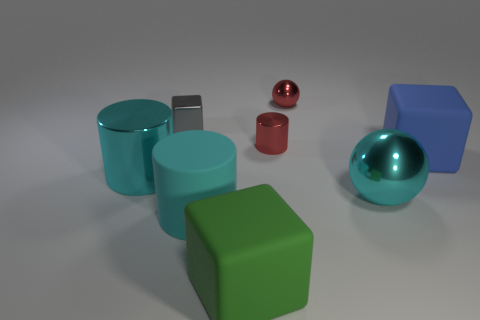How many things are cylinders to the left of the shiny cube or things on the left side of the big sphere?
Keep it short and to the point. 6. There is a big cube on the right side of the big green cube; is its color the same as the tiny metal cube?
Ensure brevity in your answer.  No. What number of other things are there of the same color as the large ball?
Offer a very short reply. 2. What is the big blue object made of?
Your response must be concise. Rubber. There is a metallic cylinder that is on the left side of the green block; does it have the same size as the large cyan metallic ball?
Offer a terse response. Yes. Are there any other things that are the same size as the gray object?
Offer a very short reply. Yes. What size is the green thing that is the same shape as the big blue object?
Provide a succinct answer. Large. Are there the same number of tiny cylinders that are on the left side of the red shiny cylinder and red metallic cylinders on the left side of the small cube?
Provide a succinct answer. Yes. What size is the cube on the right side of the tiny red sphere?
Offer a terse response. Large. Does the large metal cylinder have the same color as the tiny ball?
Offer a terse response. No. 